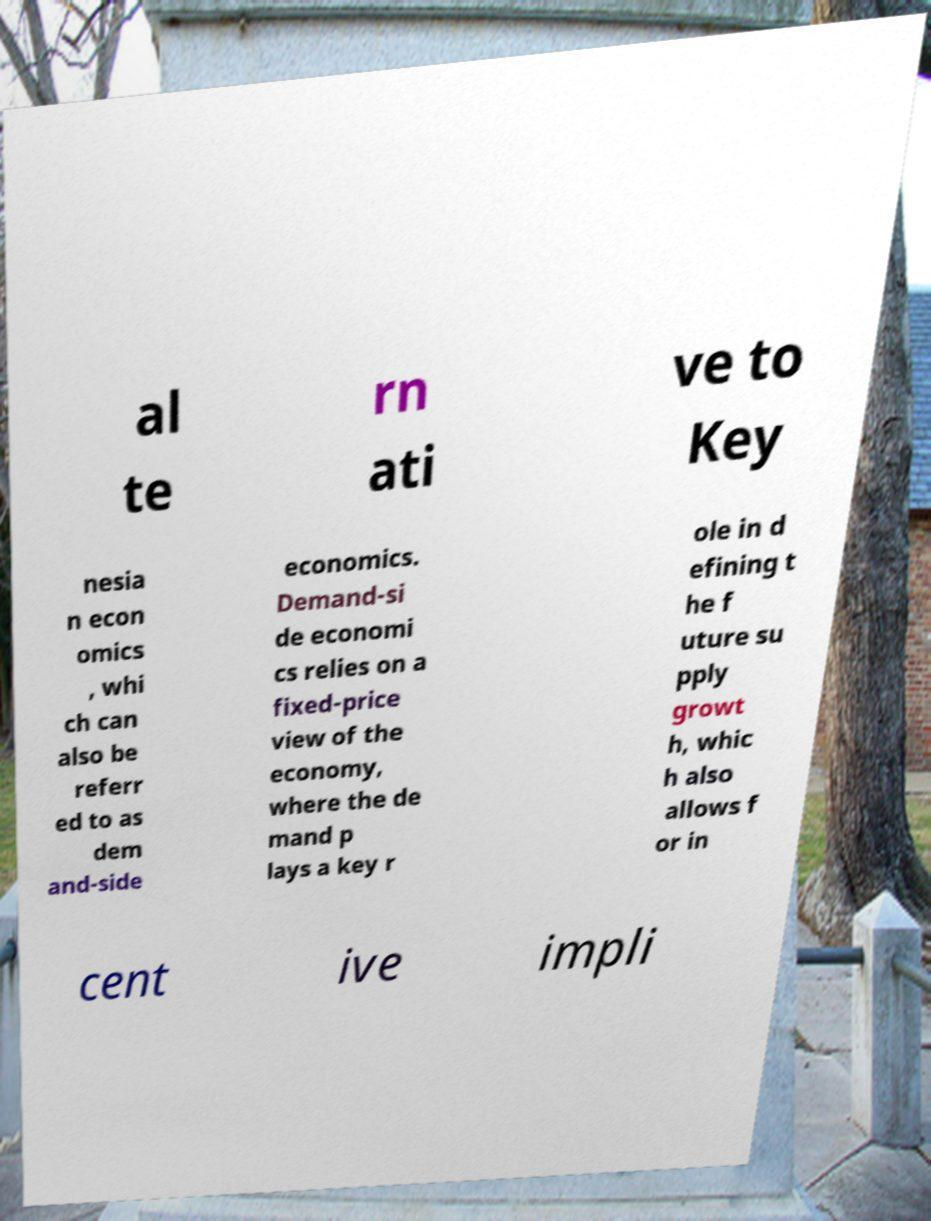I need the written content from this picture converted into text. Can you do that? al te rn ati ve to Key nesia n econ omics , whi ch can also be referr ed to as dem and-side economics. Demand-si de economi cs relies on a fixed-price view of the economy, where the de mand p lays a key r ole in d efining t he f uture su pply growt h, whic h also allows f or in cent ive impli 